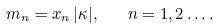<formula> <loc_0><loc_0><loc_500><loc_500>m _ { n } = x _ { n } \, | \kappa | , \quad n = 1 , 2 \dots .</formula> 